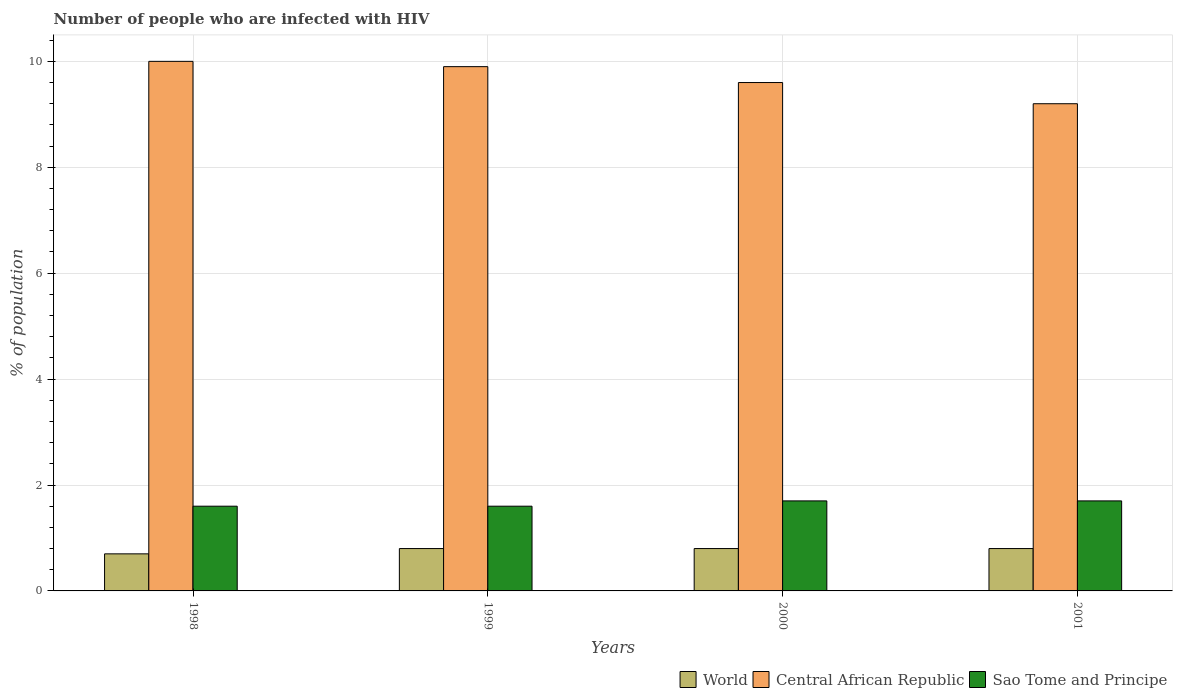How many different coloured bars are there?
Provide a succinct answer. 3. Are the number of bars on each tick of the X-axis equal?
Ensure brevity in your answer.  Yes. How many bars are there on the 4th tick from the left?
Ensure brevity in your answer.  3. How many bars are there on the 3rd tick from the right?
Your answer should be very brief. 3. What is the label of the 4th group of bars from the left?
Your response must be concise. 2001. In how many cases, is the number of bars for a given year not equal to the number of legend labels?
Offer a terse response. 0. What is the percentage of HIV infected population in in Central African Republic in 1998?
Your response must be concise. 10. What is the total percentage of HIV infected population in in Central African Republic in the graph?
Provide a succinct answer. 38.7. What is the difference between the percentage of HIV infected population in in World in 1998 and that in 1999?
Provide a succinct answer. -0.1. What is the average percentage of HIV infected population in in World per year?
Make the answer very short. 0.77. In the year 1999, what is the difference between the percentage of HIV infected population in in World and percentage of HIV infected population in in Central African Republic?
Offer a very short reply. -9.1. What is the ratio of the percentage of HIV infected population in in World in 1999 to that in 2001?
Offer a very short reply. 1. Is the percentage of HIV infected population in in Sao Tome and Principe in 1998 less than that in 2001?
Give a very brief answer. Yes. What is the difference between the highest and the lowest percentage of HIV infected population in in World?
Ensure brevity in your answer.  0.1. In how many years, is the percentage of HIV infected population in in Sao Tome and Principe greater than the average percentage of HIV infected population in in Sao Tome and Principe taken over all years?
Provide a succinct answer. 2. Is the sum of the percentage of HIV infected population in in Sao Tome and Principe in 1998 and 1999 greater than the maximum percentage of HIV infected population in in Central African Republic across all years?
Make the answer very short. No. What does the 3rd bar from the left in 2000 represents?
Offer a terse response. Sao Tome and Principe. What does the 1st bar from the right in 2000 represents?
Keep it short and to the point. Sao Tome and Principe. How many bars are there?
Your response must be concise. 12. Are all the bars in the graph horizontal?
Make the answer very short. No. Does the graph contain grids?
Your response must be concise. Yes. Where does the legend appear in the graph?
Provide a short and direct response. Bottom right. How are the legend labels stacked?
Make the answer very short. Horizontal. What is the title of the graph?
Your answer should be very brief. Number of people who are infected with HIV. What is the label or title of the X-axis?
Your answer should be very brief. Years. What is the label or title of the Y-axis?
Provide a short and direct response. % of population. What is the % of population of Sao Tome and Principe in 1998?
Your answer should be compact. 1.6. What is the % of population in World in 1999?
Your response must be concise. 0.8. What is the % of population of Central African Republic in 1999?
Your answer should be very brief. 9.9. What is the % of population in Sao Tome and Principe in 1999?
Make the answer very short. 1.6. What is the % of population of World in 2000?
Offer a very short reply. 0.8. What is the % of population in Central African Republic in 2000?
Give a very brief answer. 9.6. What is the % of population in Sao Tome and Principe in 2000?
Provide a succinct answer. 1.7. Across all years, what is the minimum % of population in World?
Offer a terse response. 0.7. Across all years, what is the minimum % of population of Central African Republic?
Offer a terse response. 9.2. What is the total % of population of Central African Republic in the graph?
Provide a short and direct response. 38.7. What is the difference between the % of population of Sao Tome and Principe in 1998 and that in 2000?
Offer a very short reply. -0.1. What is the difference between the % of population in World in 1998 and that in 2001?
Your response must be concise. -0.1. What is the difference between the % of population of Central African Republic in 1998 and that in 2001?
Keep it short and to the point. 0.8. What is the difference between the % of population in World in 1999 and that in 2001?
Your response must be concise. 0. What is the difference between the % of population in Sao Tome and Principe in 1999 and that in 2001?
Ensure brevity in your answer.  -0.1. What is the difference between the % of population of World in 1998 and the % of population of Sao Tome and Principe in 1999?
Your answer should be very brief. -0.9. What is the difference between the % of population in Central African Republic in 1998 and the % of population in Sao Tome and Principe in 1999?
Make the answer very short. 8.4. What is the difference between the % of population in World in 1999 and the % of population in Sao Tome and Principe in 2000?
Make the answer very short. -0.9. What is the average % of population in World per year?
Your answer should be compact. 0.78. What is the average % of population of Central African Republic per year?
Offer a very short reply. 9.68. What is the average % of population of Sao Tome and Principe per year?
Keep it short and to the point. 1.65. In the year 1998, what is the difference between the % of population in World and % of population in Sao Tome and Principe?
Give a very brief answer. -0.9. In the year 1999, what is the difference between the % of population of World and % of population of Central African Republic?
Offer a terse response. -9.1. In the year 1999, what is the difference between the % of population in Central African Republic and % of population in Sao Tome and Principe?
Provide a short and direct response. 8.3. In the year 2000, what is the difference between the % of population in World and % of population in Central African Republic?
Ensure brevity in your answer.  -8.8. In the year 2000, what is the difference between the % of population in World and % of population in Sao Tome and Principe?
Provide a short and direct response. -0.9. In the year 2001, what is the difference between the % of population of World and % of population of Central African Republic?
Offer a terse response. -8.4. In the year 2001, what is the difference between the % of population in World and % of population in Sao Tome and Principe?
Your response must be concise. -0.9. In the year 2001, what is the difference between the % of population of Central African Republic and % of population of Sao Tome and Principe?
Ensure brevity in your answer.  7.5. What is the ratio of the % of population in World in 1998 to that in 1999?
Your response must be concise. 0.88. What is the ratio of the % of population of Central African Republic in 1998 to that in 1999?
Your answer should be compact. 1.01. What is the ratio of the % of population in Central African Republic in 1998 to that in 2000?
Make the answer very short. 1.04. What is the ratio of the % of population in Sao Tome and Principe in 1998 to that in 2000?
Offer a terse response. 0.94. What is the ratio of the % of population of World in 1998 to that in 2001?
Your response must be concise. 0.88. What is the ratio of the % of population in Central African Republic in 1998 to that in 2001?
Your answer should be very brief. 1.09. What is the ratio of the % of population in Central African Republic in 1999 to that in 2000?
Provide a short and direct response. 1.03. What is the ratio of the % of population in Central African Republic in 1999 to that in 2001?
Offer a terse response. 1.08. What is the ratio of the % of population of World in 2000 to that in 2001?
Provide a succinct answer. 1. What is the ratio of the % of population of Central African Republic in 2000 to that in 2001?
Make the answer very short. 1.04. What is the difference between the highest and the second highest % of population of Central African Republic?
Keep it short and to the point. 0.1. What is the difference between the highest and the lowest % of population in World?
Your answer should be very brief. 0.1. What is the difference between the highest and the lowest % of population of Sao Tome and Principe?
Offer a terse response. 0.1. 